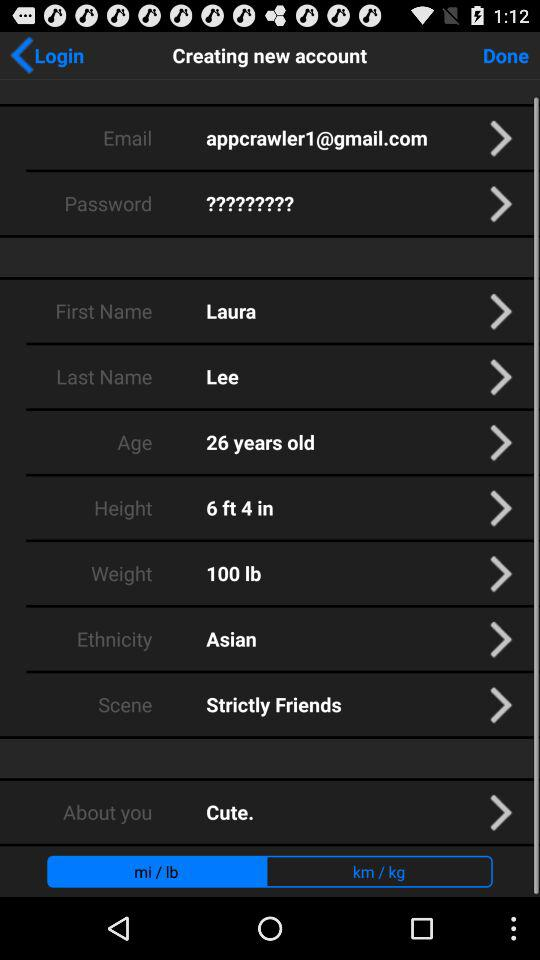What is the email address? The email address is appcrawler1@gmail.com. 